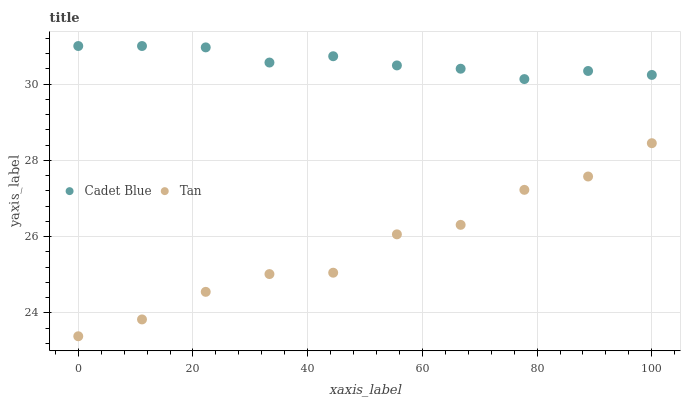Does Tan have the minimum area under the curve?
Answer yes or no. Yes. Does Cadet Blue have the maximum area under the curve?
Answer yes or no. Yes. Does Cadet Blue have the minimum area under the curve?
Answer yes or no. No. Is Cadet Blue the smoothest?
Answer yes or no. Yes. Is Tan the roughest?
Answer yes or no. Yes. Is Cadet Blue the roughest?
Answer yes or no. No. Does Tan have the lowest value?
Answer yes or no. Yes. Does Cadet Blue have the lowest value?
Answer yes or no. No. Does Cadet Blue have the highest value?
Answer yes or no. Yes. Is Tan less than Cadet Blue?
Answer yes or no. Yes. Is Cadet Blue greater than Tan?
Answer yes or no. Yes. Does Tan intersect Cadet Blue?
Answer yes or no. No. 